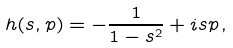<formula> <loc_0><loc_0><loc_500><loc_500>h ( s , p ) = - \frac { 1 } { 1 - s ^ { 2 } } + i s p \, ,</formula> 